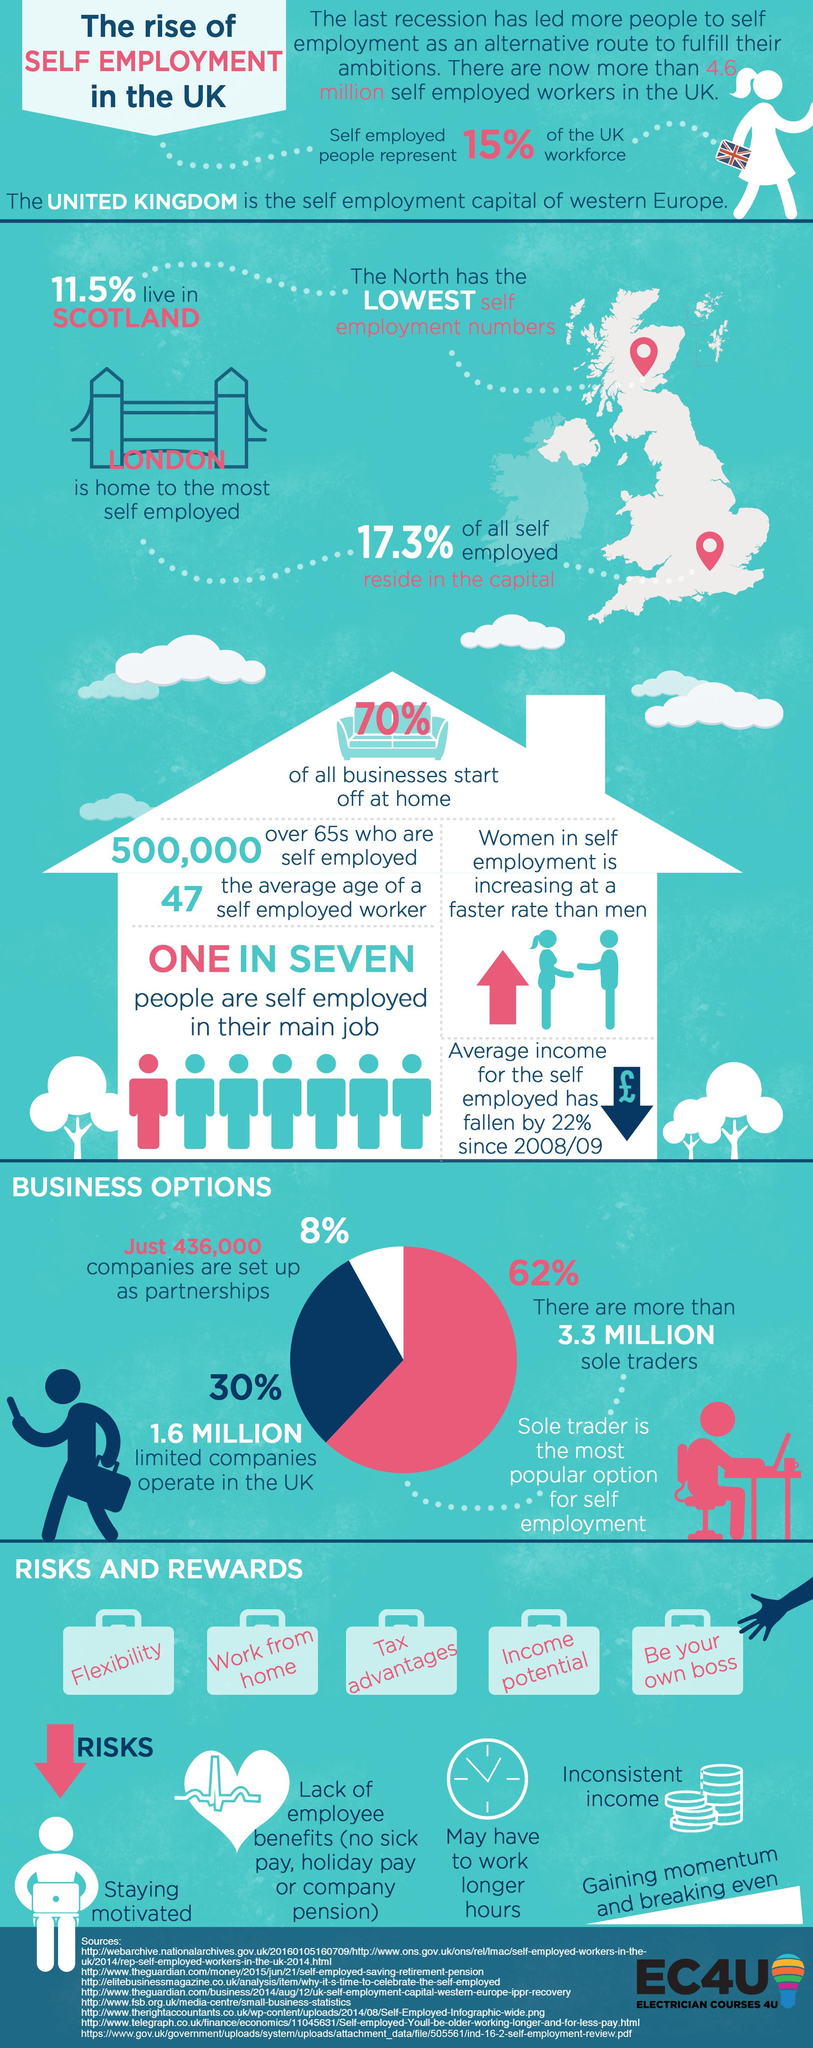Identify some key points in this picture. There are 5 rewards listed for the self-employed. The color that represents partnerships is white. The three business options available to the self-employed are partnerships, limited companies, and sole traders. The percentage of self-employed people in London is 5.8% higher than in Scotland, according to recent statistics. The list of risks for the self-employed individuals contains 5 items. 